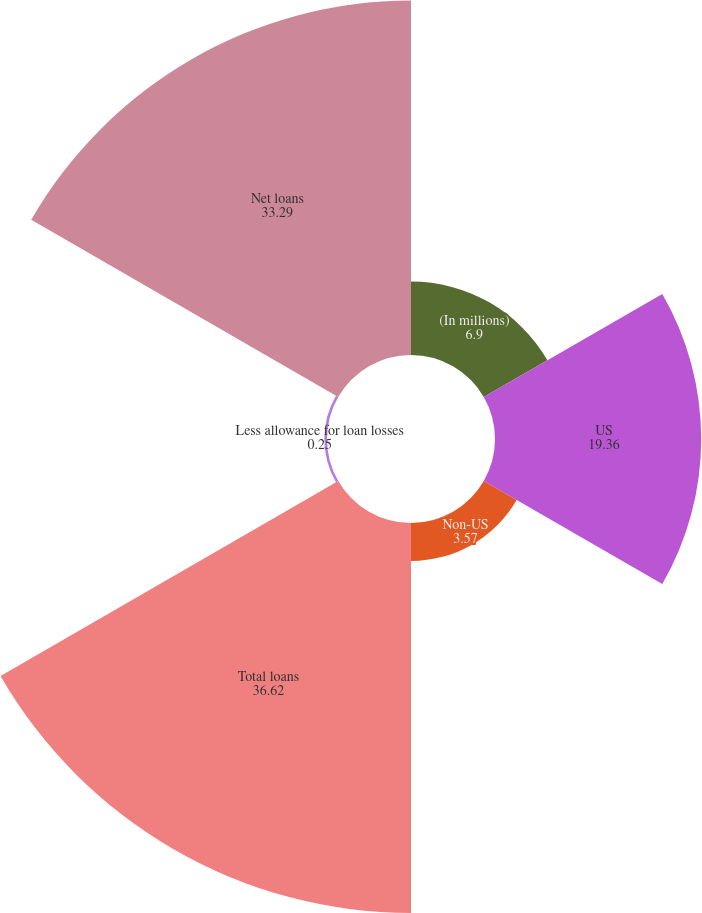<chart> <loc_0><loc_0><loc_500><loc_500><pie_chart><fcel>(In millions)<fcel>US<fcel>Non-US<fcel>Total loans<fcel>Less allowance for loan losses<fcel>Net loans<nl><fcel>6.9%<fcel>19.36%<fcel>3.57%<fcel>36.62%<fcel>0.25%<fcel>33.29%<nl></chart> 